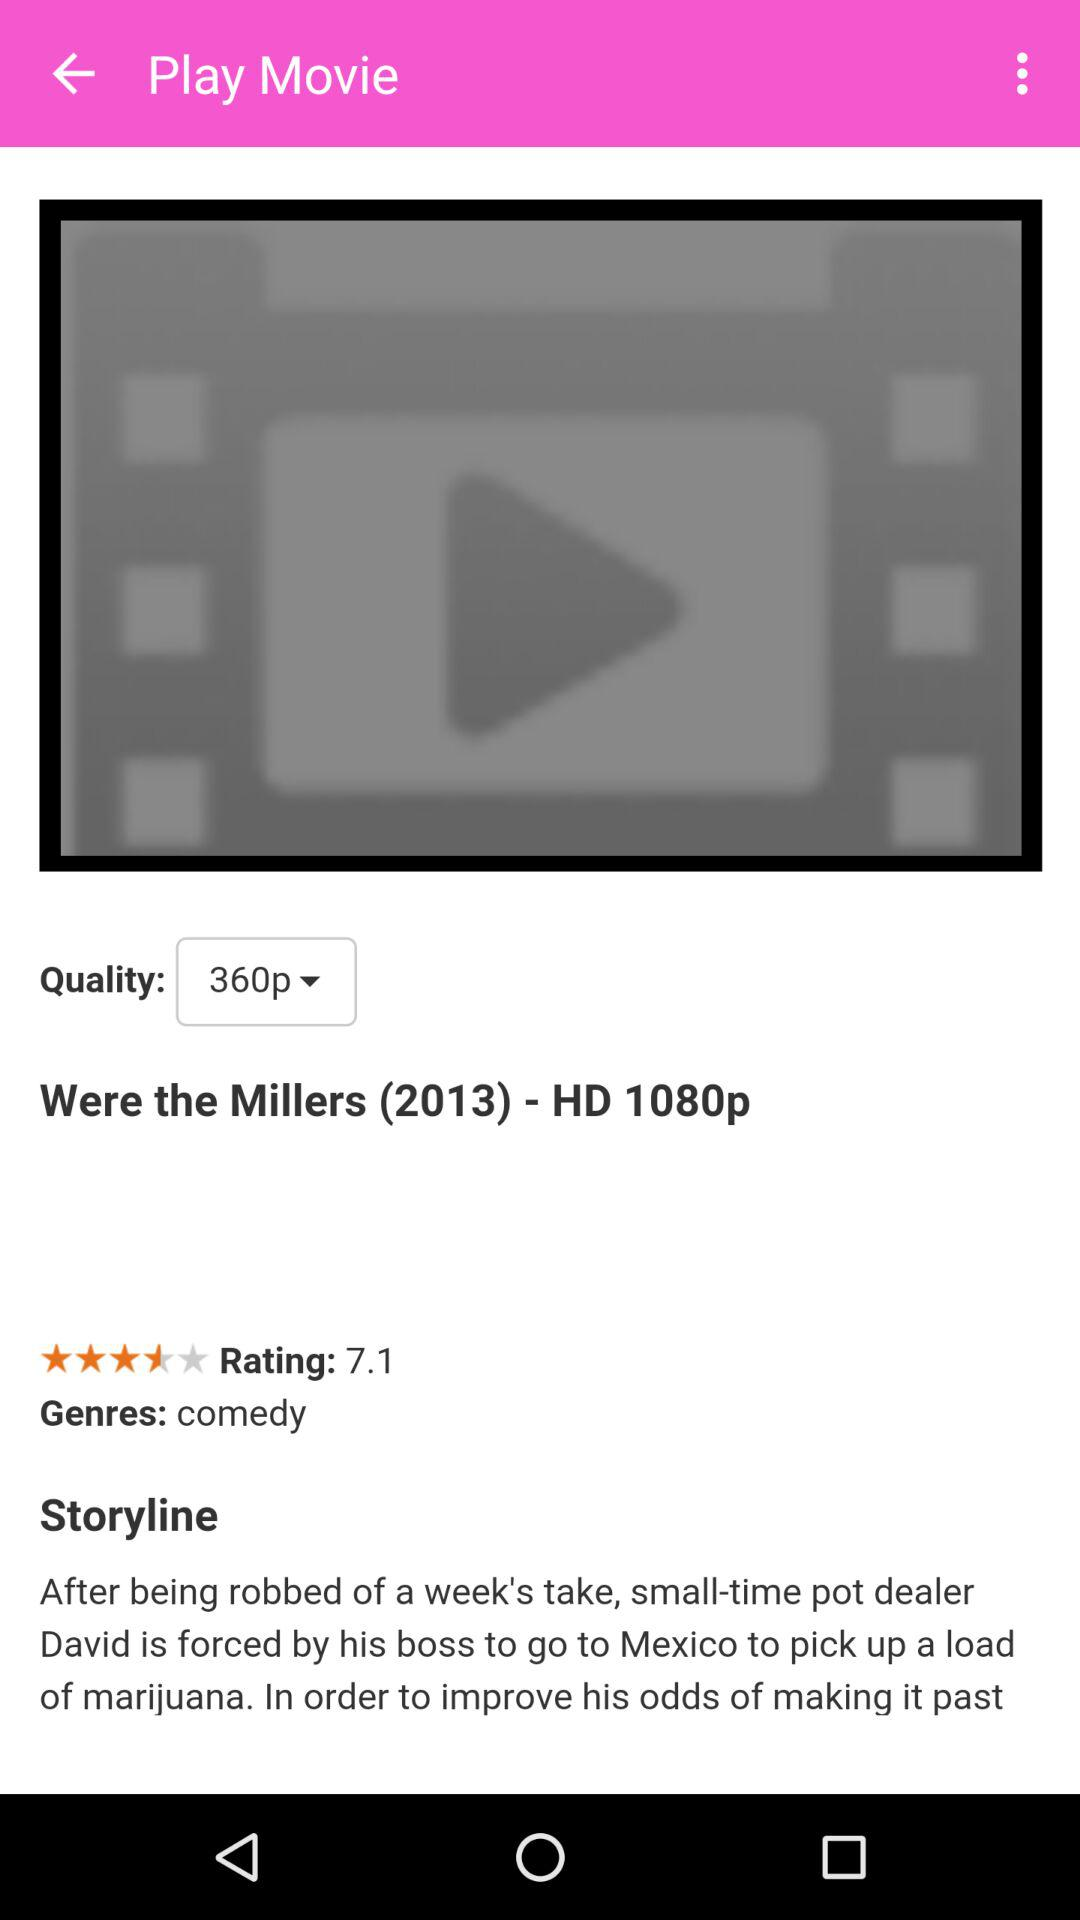What is the "Genres" type? The "Genres" type is "comedy". 